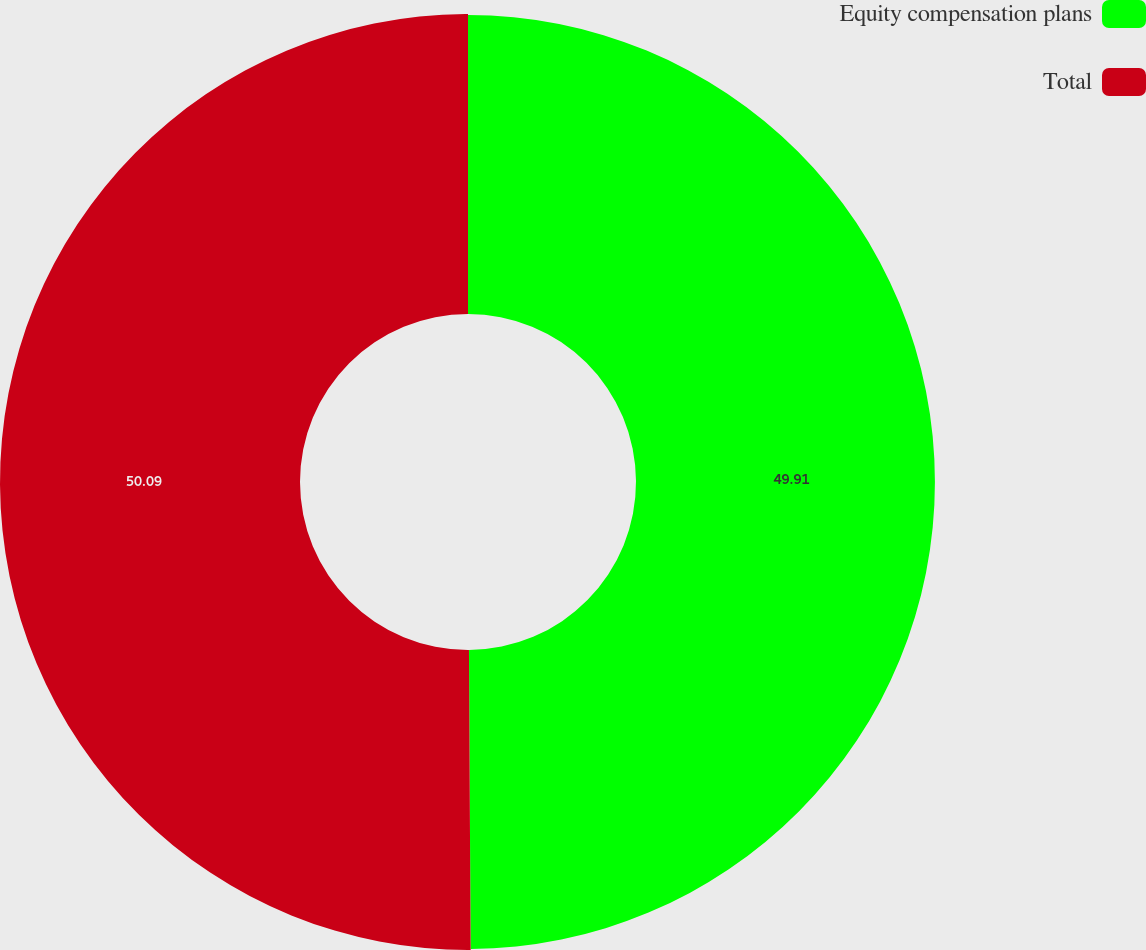<chart> <loc_0><loc_0><loc_500><loc_500><pie_chart><fcel>Equity compensation plans<fcel>Total<nl><fcel>49.91%<fcel>50.09%<nl></chart> 